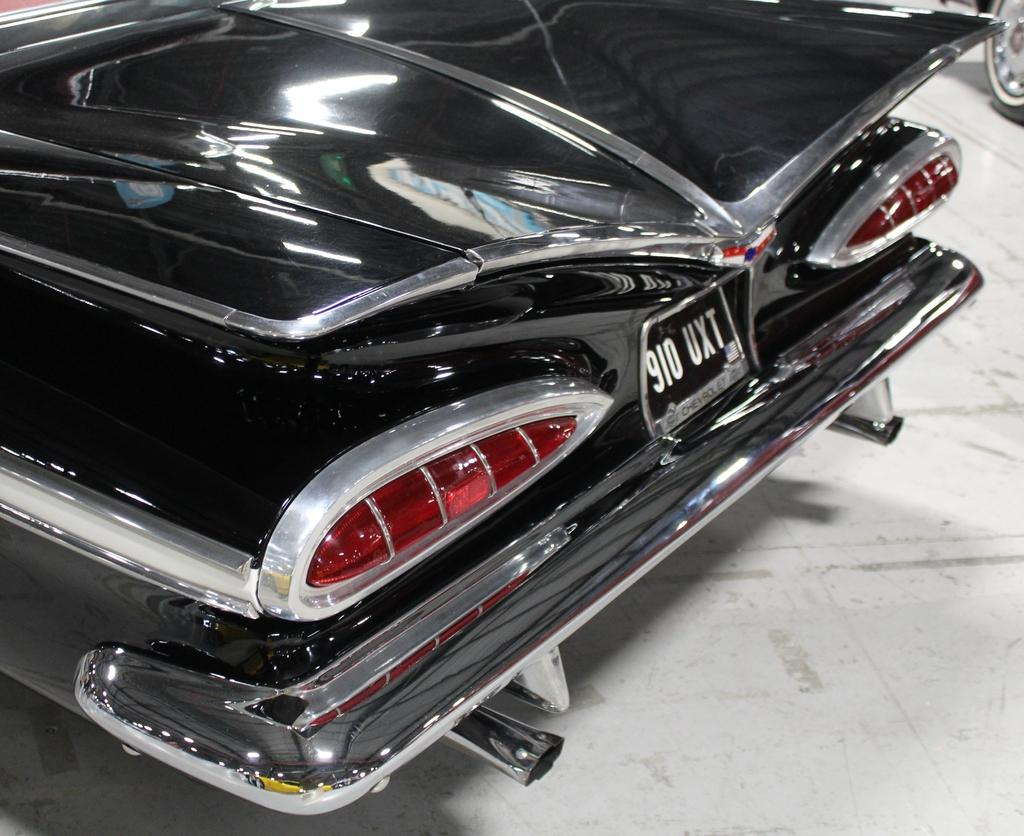What is the main subject of the image? The main subject of the image is a vehicle. Can you describe the color of the vehicle? The vehicle is black in color. How many roses are on the vehicle in the image? There are no roses present on the vehicle in the image. What type of toothpaste is being advertised on the vehicle? There is no toothpaste being advertised on the vehicle in the image. 